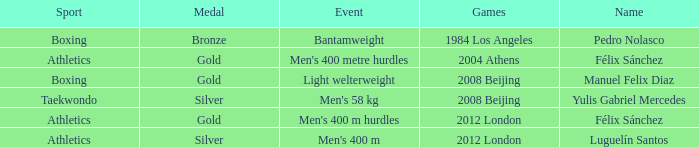What Medal had a Name of manuel felix diaz? Gold. Would you be able to parse every entry in this table? {'header': ['Sport', 'Medal', 'Event', 'Games', 'Name'], 'rows': [['Boxing', 'Bronze', 'Bantamweight', '1984 Los Angeles', 'Pedro Nolasco'], ['Athletics', 'Gold', "Men's 400 metre hurdles", '2004 Athens', 'Félix Sánchez'], ['Boxing', 'Gold', 'Light welterweight', '2008 Beijing', 'Manuel Felix Diaz'], ['Taekwondo', 'Silver', "Men's 58 kg", '2008 Beijing', 'Yulis Gabriel Mercedes'], ['Athletics', 'Gold', "Men's 400 m hurdles", '2012 London', 'Félix Sánchez'], ['Athletics', 'Silver', "Men's 400 m", '2012 London', 'Luguelín Santos']]} 